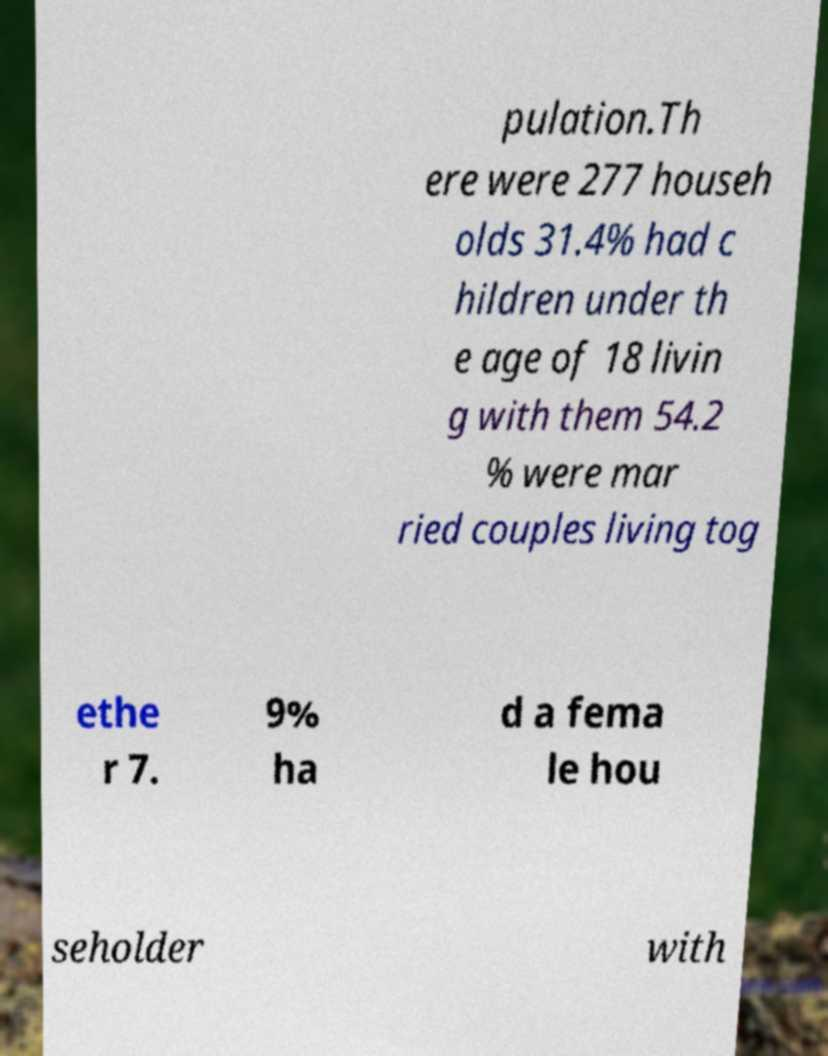What messages or text are displayed in this image? I need them in a readable, typed format. pulation.Th ere were 277 househ olds 31.4% had c hildren under th e age of 18 livin g with them 54.2 % were mar ried couples living tog ethe r 7. 9% ha d a fema le hou seholder with 